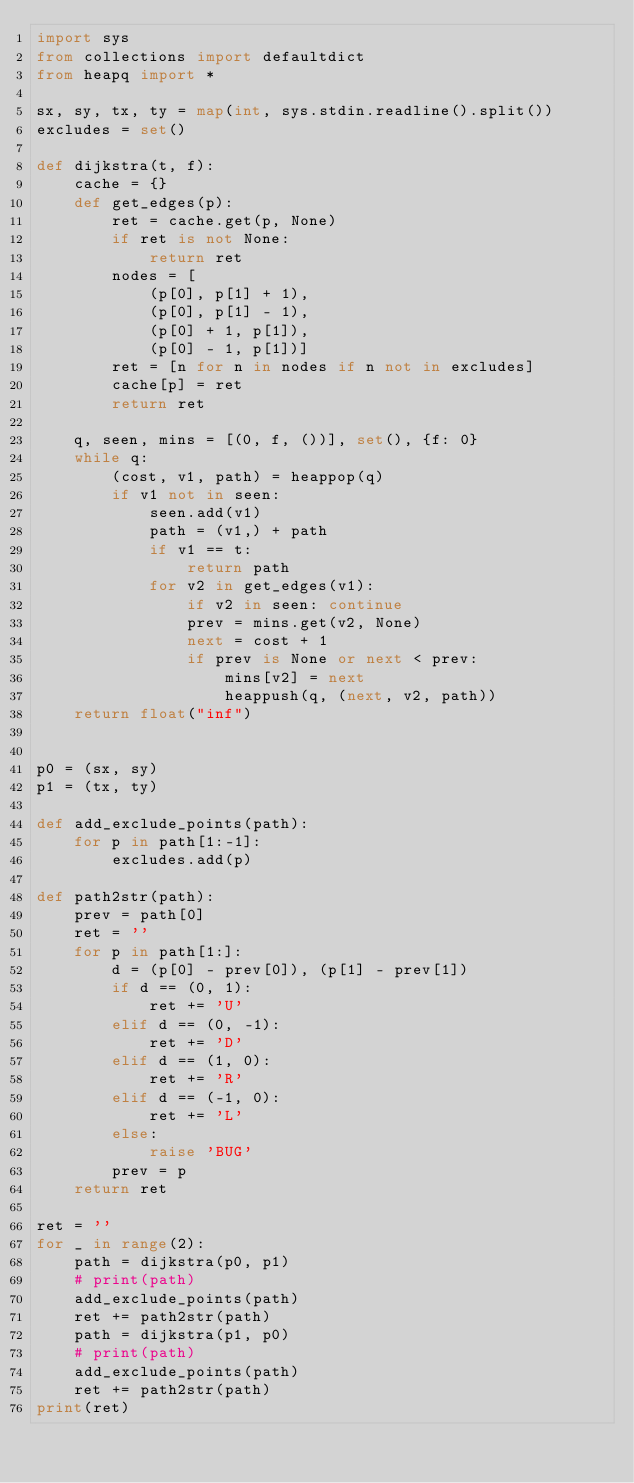<code> <loc_0><loc_0><loc_500><loc_500><_Python_>import sys
from collections import defaultdict
from heapq import *

sx, sy, tx, ty = map(int, sys.stdin.readline().split())
excludes = set()

def dijkstra(t, f):
    cache = {}
    def get_edges(p):
        ret = cache.get(p, None)
        if ret is not None:
            return ret
        nodes = [
            (p[0], p[1] + 1),
            (p[0], p[1] - 1),
            (p[0] + 1, p[1]),
            (p[0] - 1, p[1])]
        ret = [n for n in nodes if n not in excludes]
        cache[p] = ret
        return ret

    q, seen, mins = [(0, f, ())], set(), {f: 0}
    while q:
        (cost, v1, path) = heappop(q)
        if v1 not in seen:
            seen.add(v1)
            path = (v1,) + path
            if v1 == t:
                return path
            for v2 in get_edges(v1):
                if v2 in seen: continue
                prev = mins.get(v2, None)
                next = cost + 1
                if prev is None or next < prev:
                    mins[v2] = next
                    heappush(q, (next, v2, path))
    return float("inf")


p0 = (sx, sy)
p1 = (tx, ty)

def add_exclude_points(path):
    for p in path[1:-1]:
        excludes.add(p)

def path2str(path):
    prev = path[0]
    ret = ''
    for p in path[1:]:
        d = (p[0] - prev[0]), (p[1] - prev[1])
        if d == (0, 1):
            ret += 'U'
        elif d == (0, -1):
            ret += 'D'
        elif d == (1, 0):
            ret += 'R'
        elif d == (-1, 0):
            ret += 'L'
        else:
            raise 'BUG'
        prev = p
    return ret

ret = ''
for _ in range(2):
    path = dijkstra(p0, p1)
    # print(path)
    add_exclude_points(path)
    ret += path2str(path)
    path = dijkstra(p1, p0)
    # print(path)
    add_exclude_points(path)
    ret += path2str(path)
print(ret)
</code> 